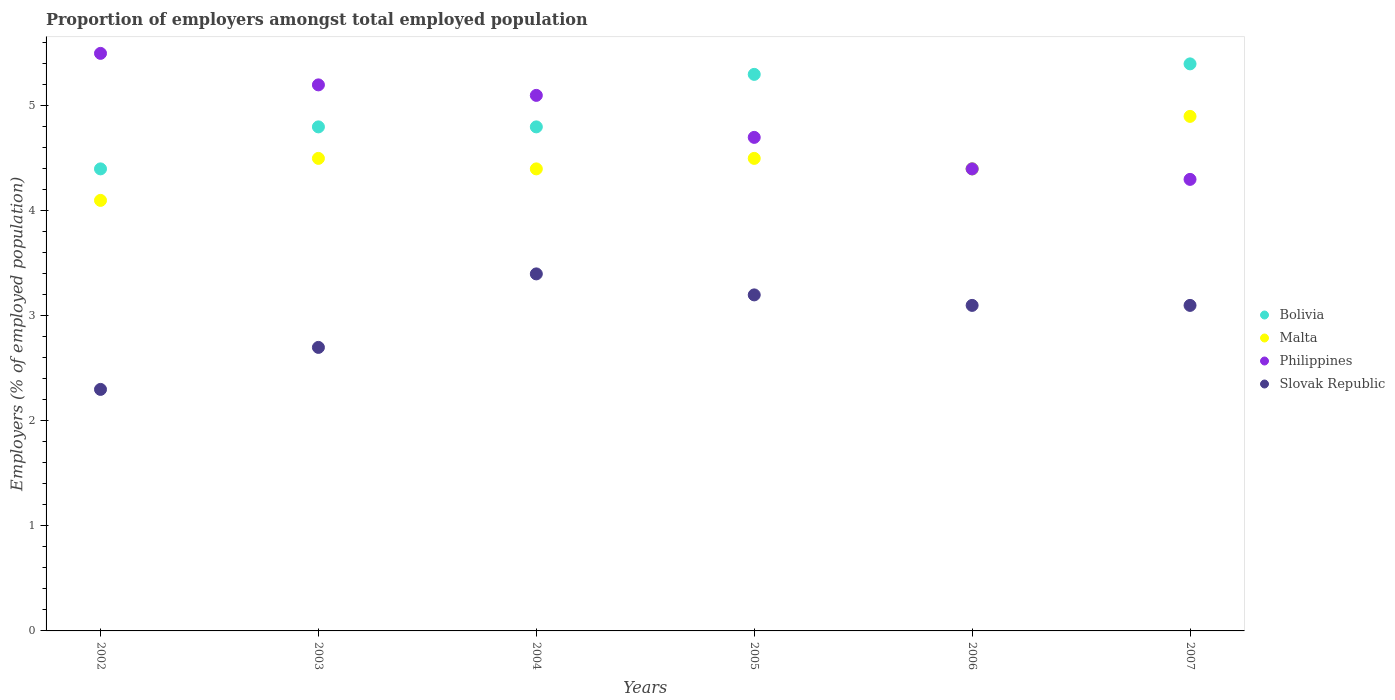What is the proportion of employers in Slovak Republic in 2003?
Give a very brief answer. 2.7. Across all years, what is the maximum proportion of employers in Philippines?
Provide a short and direct response. 5.5. Across all years, what is the minimum proportion of employers in Slovak Republic?
Ensure brevity in your answer.  2.3. In which year was the proportion of employers in Philippines maximum?
Provide a succinct answer. 2002. What is the total proportion of employers in Malta in the graph?
Provide a succinct answer. 26.8. What is the difference between the proportion of employers in Philippines in 2005 and that in 2006?
Provide a succinct answer. 0.3. What is the difference between the proportion of employers in Slovak Republic in 2006 and the proportion of employers in Malta in 2003?
Make the answer very short. -1.4. What is the average proportion of employers in Malta per year?
Provide a short and direct response. 4.47. In the year 2007, what is the difference between the proportion of employers in Philippines and proportion of employers in Slovak Republic?
Provide a succinct answer. 1.2. What is the ratio of the proportion of employers in Philippines in 2004 to that in 2005?
Offer a terse response. 1.09. Is the proportion of employers in Slovak Republic in 2003 less than that in 2007?
Give a very brief answer. Yes. What is the difference between the highest and the second highest proportion of employers in Bolivia?
Offer a terse response. 0.1. What is the difference between the highest and the lowest proportion of employers in Bolivia?
Provide a succinct answer. 1. In how many years, is the proportion of employers in Philippines greater than the average proportion of employers in Philippines taken over all years?
Your answer should be compact. 3. Does the proportion of employers in Slovak Republic monotonically increase over the years?
Offer a very short reply. No. Is the proportion of employers in Bolivia strictly greater than the proportion of employers in Philippines over the years?
Give a very brief answer. No. How many years are there in the graph?
Provide a short and direct response. 6. What is the difference between two consecutive major ticks on the Y-axis?
Make the answer very short. 1. Where does the legend appear in the graph?
Offer a very short reply. Center right. How many legend labels are there?
Make the answer very short. 4. How are the legend labels stacked?
Ensure brevity in your answer.  Vertical. What is the title of the graph?
Give a very brief answer. Proportion of employers amongst total employed population. What is the label or title of the X-axis?
Give a very brief answer. Years. What is the label or title of the Y-axis?
Your response must be concise. Employers (% of employed population). What is the Employers (% of employed population) in Bolivia in 2002?
Your answer should be compact. 4.4. What is the Employers (% of employed population) in Malta in 2002?
Offer a very short reply. 4.1. What is the Employers (% of employed population) in Philippines in 2002?
Offer a terse response. 5.5. What is the Employers (% of employed population) of Slovak Republic in 2002?
Make the answer very short. 2.3. What is the Employers (% of employed population) of Bolivia in 2003?
Keep it short and to the point. 4.8. What is the Employers (% of employed population) of Malta in 2003?
Offer a terse response. 4.5. What is the Employers (% of employed population) in Philippines in 2003?
Provide a short and direct response. 5.2. What is the Employers (% of employed population) of Slovak Republic in 2003?
Ensure brevity in your answer.  2.7. What is the Employers (% of employed population) in Bolivia in 2004?
Offer a very short reply. 4.8. What is the Employers (% of employed population) of Malta in 2004?
Offer a terse response. 4.4. What is the Employers (% of employed population) of Philippines in 2004?
Offer a terse response. 5.1. What is the Employers (% of employed population) of Slovak Republic in 2004?
Your response must be concise. 3.4. What is the Employers (% of employed population) of Bolivia in 2005?
Your answer should be very brief. 5.3. What is the Employers (% of employed population) of Philippines in 2005?
Your answer should be compact. 4.7. What is the Employers (% of employed population) in Slovak Republic in 2005?
Your answer should be very brief. 3.2. What is the Employers (% of employed population) in Bolivia in 2006?
Offer a terse response. 4.4. What is the Employers (% of employed population) of Malta in 2006?
Keep it short and to the point. 4.4. What is the Employers (% of employed population) of Philippines in 2006?
Your answer should be very brief. 4.4. What is the Employers (% of employed population) of Slovak Republic in 2006?
Give a very brief answer. 3.1. What is the Employers (% of employed population) in Bolivia in 2007?
Your answer should be very brief. 5.4. What is the Employers (% of employed population) of Malta in 2007?
Give a very brief answer. 4.9. What is the Employers (% of employed population) of Philippines in 2007?
Your answer should be very brief. 4.3. What is the Employers (% of employed population) in Slovak Republic in 2007?
Provide a short and direct response. 3.1. Across all years, what is the maximum Employers (% of employed population) of Bolivia?
Your answer should be compact. 5.4. Across all years, what is the maximum Employers (% of employed population) in Malta?
Keep it short and to the point. 4.9. Across all years, what is the maximum Employers (% of employed population) in Philippines?
Ensure brevity in your answer.  5.5. Across all years, what is the maximum Employers (% of employed population) of Slovak Republic?
Provide a succinct answer. 3.4. Across all years, what is the minimum Employers (% of employed population) of Bolivia?
Keep it short and to the point. 4.4. Across all years, what is the minimum Employers (% of employed population) in Malta?
Your answer should be very brief. 4.1. Across all years, what is the minimum Employers (% of employed population) in Philippines?
Your response must be concise. 4.3. Across all years, what is the minimum Employers (% of employed population) in Slovak Republic?
Offer a very short reply. 2.3. What is the total Employers (% of employed population) in Bolivia in the graph?
Make the answer very short. 29.1. What is the total Employers (% of employed population) in Malta in the graph?
Offer a very short reply. 26.8. What is the total Employers (% of employed population) of Philippines in the graph?
Keep it short and to the point. 29.2. What is the difference between the Employers (% of employed population) in Malta in 2002 and that in 2003?
Your response must be concise. -0.4. What is the difference between the Employers (% of employed population) in Philippines in 2002 and that in 2003?
Your answer should be very brief. 0.3. What is the difference between the Employers (% of employed population) of Slovak Republic in 2002 and that in 2003?
Ensure brevity in your answer.  -0.4. What is the difference between the Employers (% of employed population) in Bolivia in 2002 and that in 2004?
Keep it short and to the point. -0.4. What is the difference between the Employers (% of employed population) in Philippines in 2002 and that in 2004?
Provide a succinct answer. 0.4. What is the difference between the Employers (% of employed population) in Bolivia in 2002 and that in 2005?
Provide a short and direct response. -0.9. What is the difference between the Employers (% of employed population) of Malta in 2002 and that in 2005?
Offer a terse response. -0.4. What is the difference between the Employers (% of employed population) in Philippines in 2002 and that in 2005?
Offer a very short reply. 0.8. What is the difference between the Employers (% of employed population) in Slovak Republic in 2002 and that in 2005?
Provide a succinct answer. -0.9. What is the difference between the Employers (% of employed population) of Bolivia in 2002 and that in 2006?
Offer a very short reply. 0. What is the difference between the Employers (% of employed population) of Malta in 2002 and that in 2006?
Your answer should be compact. -0.3. What is the difference between the Employers (% of employed population) of Slovak Republic in 2002 and that in 2007?
Ensure brevity in your answer.  -0.8. What is the difference between the Employers (% of employed population) of Bolivia in 2003 and that in 2004?
Make the answer very short. 0. What is the difference between the Employers (% of employed population) of Slovak Republic in 2003 and that in 2004?
Your answer should be compact. -0.7. What is the difference between the Employers (% of employed population) of Bolivia in 2003 and that in 2005?
Offer a very short reply. -0.5. What is the difference between the Employers (% of employed population) of Malta in 2003 and that in 2005?
Offer a very short reply. 0. What is the difference between the Employers (% of employed population) in Malta in 2003 and that in 2007?
Offer a very short reply. -0.4. What is the difference between the Employers (% of employed population) in Philippines in 2004 and that in 2005?
Your response must be concise. 0.4. What is the difference between the Employers (% of employed population) of Slovak Republic in 2004 and that in 2005?
Ensure brevity in your answer.  0.2. What is the difference between the Employers (% of employed population) in Bolivia in 2004 and that in 2007?
Your response must be concise. -0.6. What is the difference between the Employers (% of employed population) in Philippines in 2004 and that in 2007?
Provide a short and direct response. 0.8. What is the difference between the Employers (% of employed population) in Slovak Republic in 2004 and that in 2007?
Offer a terse response. 0.3. What is the difference between the Employers (% of employed population) in Bolivia in 2005 and that in 2006?
Your answer should be very brief. 0.9. What is the difference between the Employers (% of employed population) in Slovak Republic in 2005 and that in 2006?
Provide a succinct answer. 0.1. What is the difference between the Employers (% of employed population) of Bolivia in 2005 and that in 2007?
Give a very brief answer. -0.1. What is the difference between the Employers (% of employed population) of Philippines in 2006 and that in 2007?
Keep it short and to the point. 0.1. What is the difference between the Employers (% of employed population) in Bolivia in 2002 and the Employers (% of employed population) in Malta in 2003?
Provide a short and direct response. -0.1. What is the difference between the Employers (% of employed population) of Bolivia in 2002 and the Employers (% of employed population) of Philippines in 2003?
Ensure brevity in your answer.  -0.8. What is the difference between the Employers (% of employed population) of Malta in 2002 and the Employers (% of employed population) of Slovak Republic in 2003?
Provide a succinct answer. 1.4. What is the difference between the Employers (% of employed population) of Bolivia in 2002 and the Employers (% of employed population) of Slovak Republic in 2004?
Your response must be concise. 1. What is the difference between the Employers (% of employed population) of Bolivia in 2002 and the Employers (% of employed population) of Philippines in 2005?
Offer a terse response. -0.3. What is the difference between the Employers (% of employed population) in Bolivia in 2002 and the Employers (% of employed population) in Slovak Republic in 2005?
Give a very brief answer. 1.2. What is the difference between the Employers (% of employed population) in Philippines in 2002 and the Employers (% of employed population) in Slovak Republic in 2005?
Offer a terse response. 2.3. What is the difference between the Employers (% of employed population) of Bolivia in 2002 and the Employers (% of employed population) of Philippines in 2006?
Ensure brevity in your answer.  0. What is the difference between the Employers (% of employed population) in Bolivia in 2002 and the Employers (% of employed population) in Malta in 2007?
Provide a short and direct response. -0.5. What is the difference between the Employers (% of employed population) in Bolivia in 2002 and the Employers (% of employed population) in Philippines in 2007?
Your answer should be compact. 0.1. What is the difference between the Employers (% of employed population) in Bolivia in 2002 and the Employers (% of employed population) in Slovak Republic in 2007?
Your answer should be very brief. 1.3. What is the difference between the Employers (% of employed population) of Malta in 2002 and the Employers (% of employed population) of Philippines in 2007?
Give a very brief answer. -0.2. What is the difference between the Employers (% of employed population) of Malta in 2002 and the Employers (% of employed population) of Slovak Republic in 2007?
Your response must be concise. 1. What is the difference between the Employers (% of employed population) of Bolivia in 2003 and the Employers (% of employed population) of Slovak Republic in 2004?
Make the answer very short. 1.4. What is the difference between the Employers (% of employed population) in Malta in 2003 and the Employers (% of employed population) in Slovak Republic in 2004?
Provide a short and direct response. 1.1. What is the difference between the Employers (% of employed population) of Bolivia in 2003 and the Employers (% of employed population) of Malta in 2005?
Ensure brevity in your answer.  0.3. What is the difference between the Employers (% of employed population) in Bolivia in 2003 and the Employers (% of employed population) in Philippines in 2005?
Offer a very short reply. 0.1. What is the difference between the Employers (% of employed population) of Bolivia in 2003 and the Employers (% of employed population) of Slovak Republic in 2005?
Offer a very short reply. 1.6. What is the difference between the Employers (% of employed population) in Malta in 2003 and the Employers (% of employed population) in Philippines in 2005?
Offer a terse response. -0.2. What is the difference between the Employers (% of employed population) of Malta in 2003 and the Employers (% of employed population) of Slovak Republic in 2005?
Provide a succinct answer. 1.3. What is the difference between the Employers (% of employed population) in Bolivia in 2003 and the Employers (% of employed population) in Malta in 2006?
Your response must be concise. 0.4. What is the difference between the Employers (% of employed population) of Bolivia in 2003 and the Employers (% of employed population) of Slovak Republic in 2006?
Give a very brief answer. 1.7. What is the difference between the Employers (% of employed population) of Philippines in 2003 and the Employers (% of employed population) of Slovak Republic in 2006?
Ensure brevity in your answer.  2.1. What is the difference between the Employers (% of employed population) in Bolivia in 2003 and the Employers (% of employed population) in Malta in 2007?
Your answer should be very brief. -0.1. What is the difference between the Employers (% of employed population) in Malta in 2003 and the Employers (% of employed population) in Slovak Republic in 2007?
Make the answer very short. 1.4. What is the difference between the Employers (% of employed population) in Bolivia in 2004 and the Employers (% of employed population) in Philippines in 2005?
Provide a succinct answer. 0.1. What is the difference between the Employers (% of employed population) in Bolivia in 2004 and the Employers (% of employed population) in Slovak Republic in 2005?
Your response must be concise. 1.6. What is the difference between the Employers (% of employed population) of Bolivia in 2004 and the Employers (% of employed population) of Philippines in 2006?
Your response must be concise. 0.4. What is the difference between the Employers (% of employed population) of Bolivia in 2004 and the Employers (% of employed population) of Slovak Republic in 2006?
Provide a succinct answer. 1.7. What is the difference between the Employers (% of employed population) in Malta in 2004 and the Employers (% of employed population) in Philippines in 2006?
Offer a very short reply. 0. What is the difference between the Employers (% of employed population) of Bolivia in 2004 and the Employers (% of employed population) of Malta in 2007?
Provide a short and direct response. -0.1. What is the difference between the Employers (% of employed population) of Bolivia in 2004 and the Employers (% of employed population) of Philippines in 2007?
Ensure brevity in your answer.  0.5. What is the difference between the Employers (% of employed population) in Bolivia in 2005 and the Employers (% of employed population) in Philippines in 2006?
Provide a succinct answer. 0.9. What is the difference between the Employers (% of employed population) of Bolivia in 2005 and the Employers (% of employed population) of Slovak Republic in 2006?
Your response must be concise. 2.2. What is the difference between the Employers (% of employed population) of Malta in 2005 and the Employers (% of employed population) of Slovak Republic in 2006?
Your answer should be compact. 1.4. What is the difference between the Employers (% of employed population) in Philippines in 2005 and the Employers (% of employed population) in Slovak Republic in 2006?
Ensure brevity in your answer.  1.6. What is the difference between the Employers (% of employed population) in Bolivia in 2005 and the Employers (% of employed population) in Malta in 2007?
Your response must be concise. 0.4. What is the difference between the Employers (% of employed population) in Bolivia in 2005 and the Employers (% of employed population) in Philippines in 2007?
Your response must be concise. 1. What is the difference between the Employers (% of employed population) in Bolivia in 2005 and the Employers (% of employed population) in Slovak Republic in 2007?
Your answer should be very brief. 2.2. What is the difference between the Employers (% of employed population) of Malta in 2005 and the Employers (% of employed population) of Philippines in 2007?
Offer a very short reply. 0.2. What is the difference between the Employers (% of employed population) in Philippines in 2005 and the Employers (% of employed population) in Slovak Republic in 2007?
Provide a short and direct response. 1.6. What is the difference between the Employers (% of employed population) in Bolivia in 2006 and the Employers (% of employed population) in Philippines in 2007?
Provide a succinct answer. 0.1. What is the difference between the Employers (% of employed population) of Bolivia in 2006 and the Employers (% of employed population) of Slovak Republic in 2007?
Your answer should be very brief. 1.3. What is the difference between the Employers (% of employed population) of Philippines in 2006 and the Employers (% of employed population) of Slovak Republic in 2007?
Ensure brevity in your answer.  1.3. What is the average Employers (% of employed population) in Bolivia per year?
Offer a terse response. 4.85. What is the average Employers (% of employed population) of Malta per year?
Your answer should be compact. 4.47. What is the average Employers (% of employed population) in Philippines per year?
Your response must be concise. 4.87. What is the average Employers (% of employed population) in Slovak Republic per year?
Ensure brevity in your answer.  2.97. In the year 2002, what is the difference between the Employers (% of employed population) of Bolivia and Employers (% of employed population) of Philippines?
Give a very brief answer. -1.1. In the year 2002, what is the difference between the Employers (% of employed population) of Bolivia and Employers (% of employed population) of Slovak Republic?
Your answer should be very brief. 2.1. In the year 2002, what is the difference between the Employers (% of employed population) of Malta and Employers (% of employed population) of Slovak Republic?
Make the answer very short. 1.8. In the year 2003, what is the difference between the Employers (% of employed population) in Bolivia and Employers (% of employed population) in Malta?
Your answer should be compact. 0.3. In the year 2003, what is the difference between the Employers (% of employed population) of Bolivia and Employers (% of employed population) of Philippines?
Your answer should be compact. -0.4. In the year 2003, what is the difference between the Employers (% of employed population) in Malta and Employers (% of employed population) in Slovak Republic?
Your response must be concise. 1.8. In the year 2004, what is the difference between the Employers (% of employed population) in Bolivia and Employers (% of employed population) in Malta?
Make the answer very short. 0.4. In the year 2004, what is the difference between the Employers (% of employed population) in Malta and Employers (% of employed population) in Philippines?
Offer a very short reply. -0.7. In the year 2004, what is the difference between the Employers (% of employed population) in Philippines and Employers (% of employed population) in Slovak Republic?
Keep it short and to the point. 1.7. In the year 2005, what is the difference between the Employers (% of employed population) of Bolivia and Employers (% of employed population) of Philippines?
Keep it short and to the point. 0.6. In the year 2005, what is the difference between the Employers (% of employed population) of Bolivia and Employers (% of employed population) of Slovak Republic?
Your response must be concise. 2.1. In the year 2006, what is the difference between the Employers (% of employed population) of Malta and Employers (% of employed population) of Philippines?
Ensure brevity in your answer.  0. In the year 2006, what is the difference between the Employers (% of employed population) in Malta and Employers (% of employed population) in Slovak Republic?
Provide a short and direct response. 1.3. In the year 2007, what is the difference between the Employers (% of employed population) of Bolivia and Employers (% of employed population) of Malta?
Offer a terse response. 0.5. In the year 2007, what is the difference between the Employers (% of employed population) in Bolivia and Employers (% of employed population) in Slovak Republic?
Offer a very short reply. 2.3. In the year 2007, what is the difference between the Employers (% of employed population) in Malta and Employers (% of employed population) in Slovak Republic?
Your response must be concise. 1.8. In the year 2007, what is the difference between the Employers (% of employed population) of Philippines and Employers (% of employed population) of Slovak Republic?
Keep it short and to the point. 1.2. What is the ratio of the Employers (% of employed population) in Bolivia in 2002 to that in 2003?
Provide a succinct answer. 0.92. What is the ratio of the Employers (% of employed population) of Malta in 2002 to that in 2003?
Your response must be concise. 0.91. What is the ratio of the Employers (% of employed population) of Philippines in 2002 to that in 2003?
Keep it short and to the point. 1.06. What is the ratio of the Employers (% of employed population) in Slovak Republic in 2002 to that in 2003?
Make the answer very short. 0.85. What is the ratio of the Employers (% of employed population) of Bolivia in 2002 to that in 2004?
Provide a succinct answer. 0.92. What is the ratio of the Employers (% of employed population) in Malta in 2002 to that in 2004?
Provide a succinct answer. 0.93. What is the ratio of the Employers (% of employed population) of Philippines in 2002 to that in 2004?
Offer a very short reply. 1.08. What is the ratio of the Employers (% of employed population) in Slovak Republic in 2002 to that in 2004?
Give a very brief answer. 0.68. What is the ratio of the Employers (% of employed population) in Bolivia in 2002 to that in 2005?
Your response must be concise. 0.83. What is the ratio of the Employers (% of employed population) of Malta in 2002 to that in 2005?
Offer a terse response. 0.91. What is the ratio of the Employers (% of employed population) of Philippines in 2002 to that in 2005?
Your answer should be compact. 1.17. What is the ratio of the Employers (% of employed population) in Slovak Republic in 2002 to that in 2005?
Provide a succinct answer. 0.72. What is the ratio of the Employers (% of employed population) in Bolivia in 2002 to that in 2006?
Offer a very short reply. 1. What is the ratio of the Employers (% of employed population) of Malta in 2002 to that in 2006?
Make the answer very short. 0.93. What is the ratio of the Employers (% of employed population) of Philippines in 2002 to that in 2006?
Your answer should be compact. 1.25. What is the ratio of the Employers (% of employed population) of Slovak Republic in 2002 to that in 2006?
Your response must be concise. 0.74. What is the ratio of the Employers (% of employed population) in Bolivia in 2002 to that in 2007?
Provide a short and direct response. 0.81. What is the ratio of the Employers (% of employed population) of Malta in 2002 to that in 2007?
Your answer should be compact. 0.84. What is the ratio of the Employers (% of employed population) in Philippines in 2002 to that in 2007?
Keep it short and to the point. 1.28. What is the ratio of the Employers (% of employed population) of Slovak Republic in 2002 to that in 2007?
Give a very brief answer. 0.74. What is the ratio of the Employers (% of employed population) of Bolivia in 2003 to that in 2004?
Provide a succinct answer. 1. What is the ratio of the Employers (% of employed population) of Malta in 2003 to that in 2004?
Offer a very short reply. 1.02. What is the ratio of the Employers (% of employed population) of Philippines in 2003 to that in 2004?
Offer a terse response. 1.02. What is the ratio of the Employers (% of employed population) of Slovak Republic in 2003 to that in 2004?
Ensure brevity in your answer.  0.79. What is the ratio of the Employers (% of employed population) in Bolivia in 2003 to that in 2005?
Provide a succinct answer. 0.91. What is the ratio of the Employers (% of employed population) in Malta in 2003 to that in 2005?
Keep it short and to the point. 1. What is the ratio of the Employers (% of employed population) in Philippines in 2003 to that in 2005?
Provide a short and direct response. 1.11. What is the ratio of the Employers (% of employed population) of Slovak Republic in 2003 to that in 2005?
Provide a succinct answer. 0.84. What is the ratio of the Employers (% of employed population) of Bolivia in 2003 to that in 2006?
Keep it short and to the point. 1.09. What is the ratio of the Employers (% of employed population) in Malta in 2003 to that in 2006?
Make the answer very short. 1.02. What is the ratio of the Employers (% of employed population) in Philippines in 2003 to that in 2006?
Offer a terse response. 1.18. What is the ratio of the Employers (% of employed population) of Slovak Republic in 2003 to that in 2006?
Your answer should be very brief. 0.87. What is the ratio of the Employers (% of employed population) of Bolivia in 2003 to that in 2007?
Your answer should be compact. 0.89. What is the ratio of the Employers (% of employed population) of Malta in 2003 to that in 2007?
Provide a short and direct response. 0.92. What is the ratio of the Employers (% of employed population) in Philippines in 2003 to that in 2007?
Your response must be concise. 1.21. What is the ratio of the Employers (% of employed population) in Slovak Republic in 2003 to that in 2007?
Offer a very short reply. 0.87. What is the ratio of the Employers (% of employed population) of Bolivia in 2004 to that in 2005?
Provide a succinct answer. 0.91. What is the ratio of the Employers (% of employed population) of Malta in 2004 to that in 2005?
Provide a succinct answer. 0.98. What is the ratio of the Employers (% of employed population) of Philippines in 2004 to that in 2005?
Ensure brevity in your answer.  1.09. What is the ratio of the Employers (% of employed population) in Slovak Republic in 2004 to that in 2005?
Give a very brief answer. 1.06. What is the ratio of the Employers (% of employed population) in Bolivia in 2004 to that in 2006?
Keep it short and to the point. 1.09. What is the ratio of the Employers (% of employed population) of Malta in 2004 to that in 2006?
Your response must be concise. 1. What is the ratio of the Employers (% of employed population) in Philippines in 2004 to that in 2006?
Your answer should be very brief. 1.16. What is the ratio of the Employers (% of employed population) in Slovak Republic in 2004 to that in 2006?
Provide a succinct answer. 1.1. What is the ratio of the Employers (% of employed population) of Malta in 2004 to that in 2007?
Offer a very short reply. 0.9. What is the ratio of the Employers (% of employed population) in Philippines in 2004 to that in 2007?
Make the answer very short. 1.19. What is the ratio of the Employers (% of employed population) of Slovak Republic in 2004 to that in 2007?
Keep it short and to the point. 1.1. What is the ratio of the Employers (% of employed population) in Bolivia in 2005 to that in 2006?
Ensure brevity in your answer.  1.2. What is the ratio of the Employers (% of employed population) in Malta in 2005 to that in 2006?
Ensure brevity in your answer.  1.02. What is the ratio of the Employers (% of employed population) of Philippines in 2005 to that in 2006?
Give a very brief answer. 1.07. What is the ratio of the Employers (% of employed population) of Slovak Republic in 2005 to that in 2006?
Your response must be concise. 1.03. What is the ratio of the Employers (% of employed population) in Bolivia in 2005 to that in 2007?
Your answer should be very brief. 0.98. What is the ratio of the Employers (% of employed population) of Malta in 2005 to that in 2007?
Your answer should be very brief. 0.92. What is the ratio of the Employers (% of employed population) in Philippines in 2005 to that in 2007?
Make the answer very short. 1.09. What is the ratio of the Employers (% of employed population) of Slovak Republic in 2005 to that in 2007?
Offer a very short reply. 1.03. What is the ratio of the Employers (% of employed population) of Bolivia in 2006 to that in 2007?
Give a very brief answer. 0.81. What is the ratio of the Employers (% of employed population) of Malta in 2006 to that in 2007?
Offer a very short reply. 0.9. What is the ratio of the Employers (% of employed population) in Philippines in 2006 to that in 2007?
Keep it short and to the point. 1.02. What is the ratio of the Employers (% of employed population) of Slovak Republic in 2006 to that in 2007?
Offer a very short reply. 1. What is the difference between the highest and the second highest Employers (% of employed population) of Malta?
Make the answer very short. 0.4. What is the difference between the highest and the lowest Employers (% of employed population) of Philippines?
Give a very brief answer. 1.2. What is the difference between the highest and the lowest Employers (% of employed population) in Slovak Republic?
Keep it short and to the point. 1.1. 